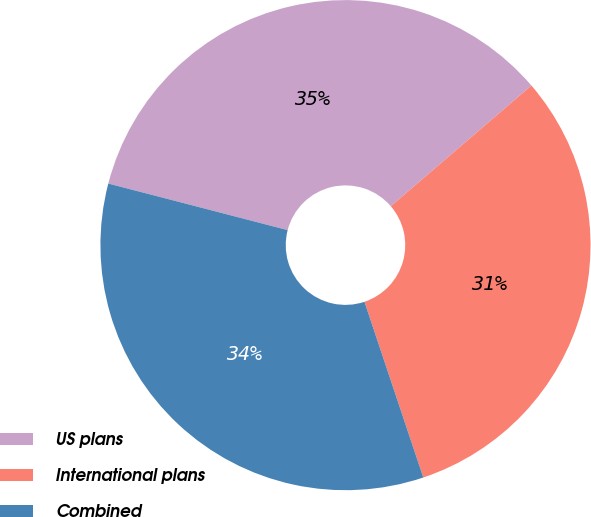Convert chart. <chart><loc_0><loc_0><loc_500><loc_500><pie_chart><fcel>US plans<fcel>International plans<fcel>Combined<nl><fcel>34.67%<fcel>31.15%<fcel>34.19%<nl></chart> 